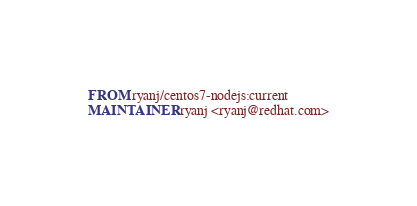Convert code to text. <code><loc_0><loc_0><loc_500><loc_500><_Dockerfile_>FROM ryanj/centos7-nodejs:current
MAINTAINER ryanj <ryanj@redhat.com></code> 